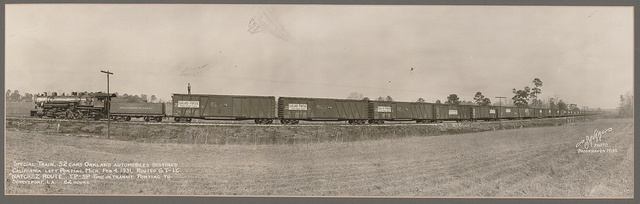Describe the objects in this image and their specific colors. I can see train in gray, black, and darkgray tones and people in gray, darkgray, and darkgreen tones in this image. 